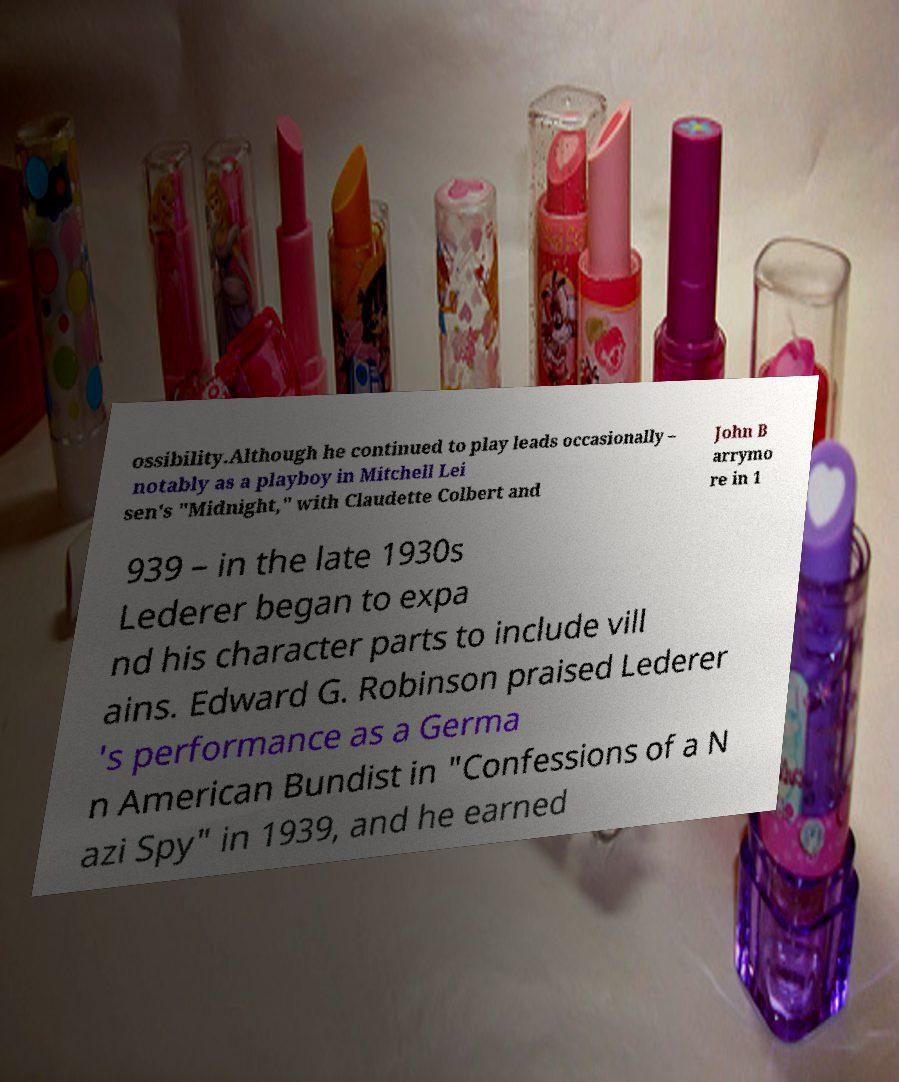I need the written content from this picture converted into text. Can you do that? ossibility.Although he continued to play leads occasionally – notably as a playboy in Mitchell Lei sen's "Midnight," with Claudette Colbert and John B arrymo re in 1 939 – in the late 1930s Lederer began to expa nd his character parts to include vill ains. Edward G. Robinson praised Lederer 's performance as a Germa n American Bundist in "Confessions of a N azi Spy" in 1939, and he earned 